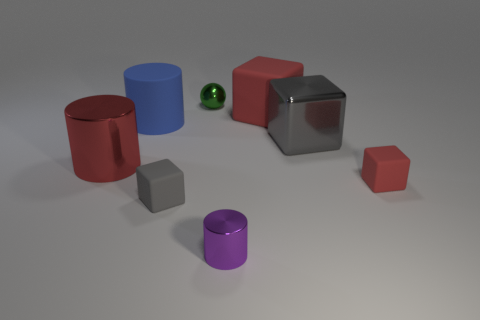Are there any other things that are the same color as the small sphere?
Your answer should be compact. No. How many metal objects are large yellow blocks or tiny red blocks?
Your answer should be very brief. 0. What is the shape of the tiny thing that is the same color as the big rubber cube?
Your response must be concise. Cube. How many big gray things are there?
Your answer should be compact. 1. Are the red thing to the left of the tiny ball and the cylinder to the right of the small gray matte thing made of the same material?
Give a very brief answer. Yes. What size is the block that is the same material as the red cylinder?
Provide a succinct answer. Large. There is a large red object that is to the right of the small purple object; what shape is it?
Your answer should be compact. Cube. Does the big shiny object behind the large red metallic cylinder have the same color as the rubber block that is to the left of the big red cube?
Provide a short and direct response. Yes. There is a cylinder that is the same color as the big matte cube; what size is it?
Keep it short and to the point. Large. Is there a gray cube?
Make the answer very short. Yes. 